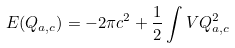Convert formula to latex. <formula><loc_0><loc_0><loc_500><loc_500>E ( Q _ { a , c } ) = - 2 \pi c ^ { 2 } + \frac { 1 } { 2 } \int V Q _ { a , c } ^ { 2 }</formula> 